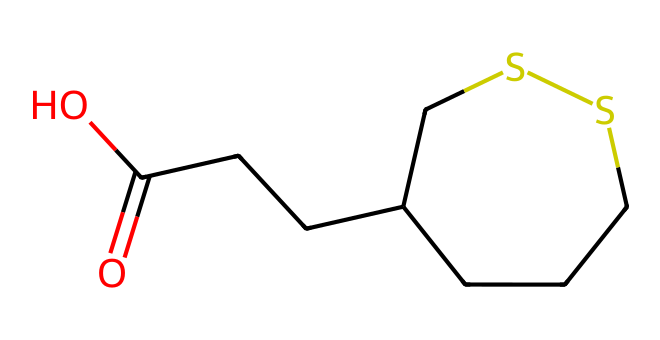What is the name of this chemical? The SMILES representation corresponds to lipoic acid, which is known for its antioxidant properties.
Answer: lipoic acid How many carbon atoms are in this molecule? By analyzing the SMILES, we see that there are a total of 8 carbon (C) atoms present.
Answer: 8 What type of functional group is present in this structure? The presence of the -COOH indicates that this compound has a carboxylic acid functional group.
Answer: carboxylic acid What functional role does the sulfur play in this molecule? The sulfur atoms in lipoic acid play a crucial role in its biochemical functions, often involved in redox reactions as they can exist in both oxidized and reduced states.
Answer: redox How many oxygen atoms are in this chemical structure? The SMILES indicates there are two oxygen (O) atoms due to the presence of the carboxylic acid group.
Answer: 2 Which part of the molecule contributes to its antioxidant properties? The sulfur atoms are central to its antioxidant activity, as they help in the regeneration of other antioxidants and in reducing oxidative stress.
Answer: sulfur atoms Is lipoic acid a hydrophilic or hydrophobic compound? Given the presence of both polar (carboxylic acid) and non-polar components, lipoic acid can interact with both water and lipids, making it amphipathic.
Answer: amphipathic 